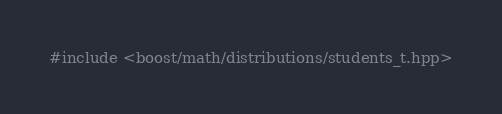<code> <loc_0><loc_0><loc_500><loc_500><_C++_>#include <boost/math/distributions/students_t.hpp>
</code> 